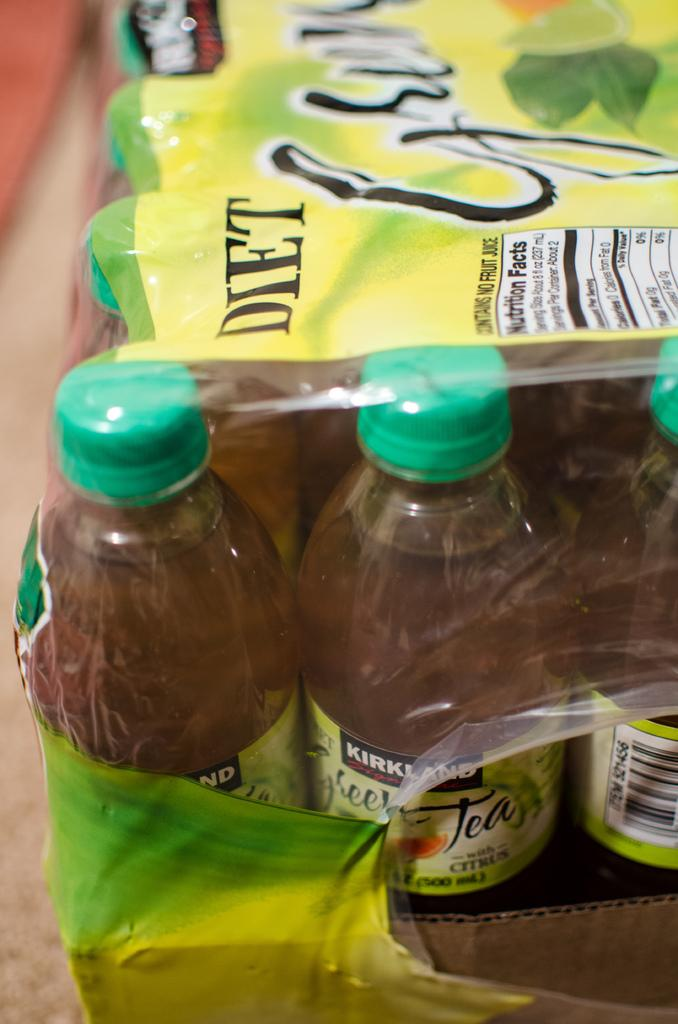<image>
Relay a brief, clear account of the picture shown. A pack of Diet green tea bottles covered by a yellow and green plastic. 